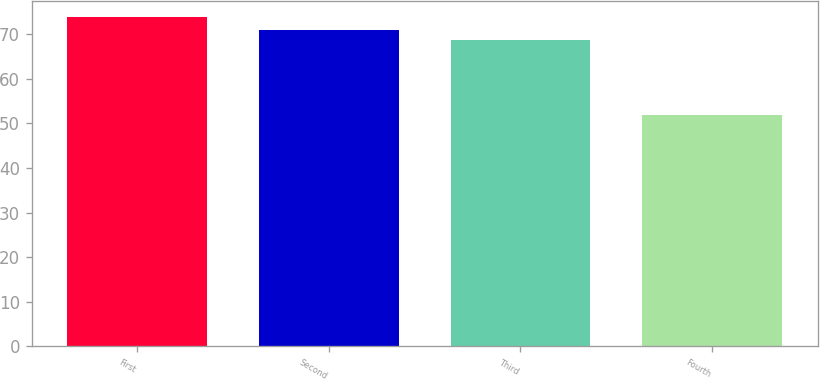Convert chart. <chart><loc_0><loc_0><loc_500><loc_500><bar_chart><fcel>First<fcel>Second<fcel>Third<fcel>Fourth<nl><fcel>73.75<fcel>70.95<fcel>68.76<fcel>51.87<nl></chart> 